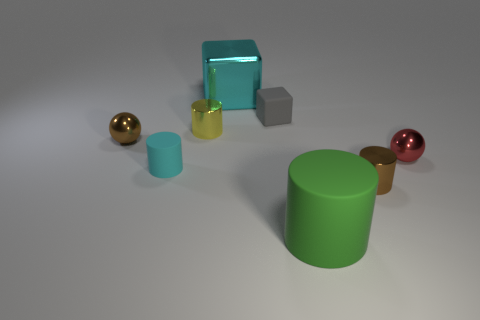Are there the same number of tiny gray matte things on the right side of the small matte cube and large matte objects right of the big metal cube?
Ensure brevity in your answer.  No. What color is the small shiny ball that is to the left of the rubber cylinder behind the small brown object to the right of the large cyan metallic thing?
Ensure brevity in your answer.  Brown. There is a matte thing that is behind the tiny brown ball; what is its shape?
Your response must be concise. Cube. What is the shape of the big cyan object that is the same material as the red object?
Offer a terse response. Cube. Is there anything else that has the same shape as the yellow thing?
Your answer should be very brief. Yes. There is a large cyan cube; what number of large rubber cylinders are left of it?
Provide a short and direct response. 0. Are there the same number of shiny spheres right of the green rubber object and cyan matte cylinders?
Offer a very short reply. Yes. Are the large green thing and the big cyan block made of the same material?
Give a very brief answer. No. How big is the matte thing that is both in front of the red metallic thing and behind the big green matte cylinder?
Offer a terse response. Small. What number of purple spheres are the same size as the red object?
Give a very brief answer. 0. 